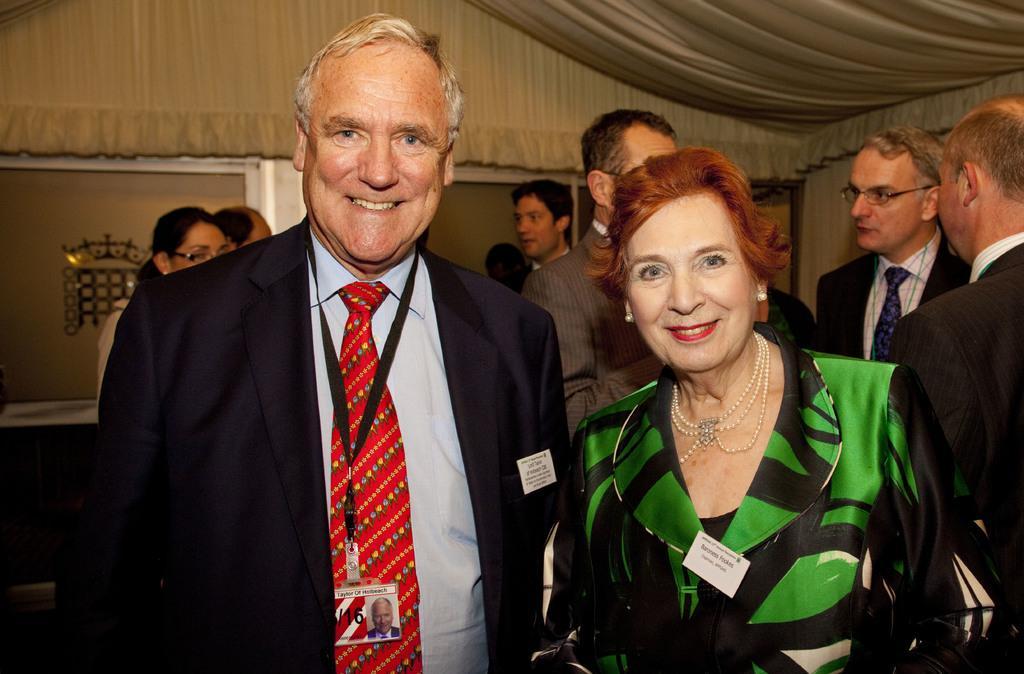Can you describe this image briefly? In this picture there is a man who is standing near to the woman. In the back I can see many persons who are standing near to the wall and door. At the top I can see the clothes. 